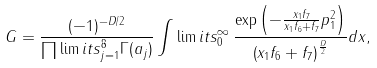Convert formula to latex. <formula><loc_0><loc_0><loc_500><loc_500>G = \frac { ( - 1 ) ^ { - D / 2 } } { \prod \lim i t s _ { j = 1 } ^ { 8 } \Gamma ( a _ { j } ) } \int \lim i t s _ { 0 } ^ { \infty } \, \frac { \exp \left ( - \frac { x _ { 1 } f _ { 7 } } { x _ { 1 } f _ { 6 } + f _ { 7 } } p _ { 1 } ^ { 2 } \right ) } { \left ( x _ { 1 } f _ { 6 } + f _ { 7 } \right ) ^ { \frac { D } { 2 } } } { d x } ,</formula> 